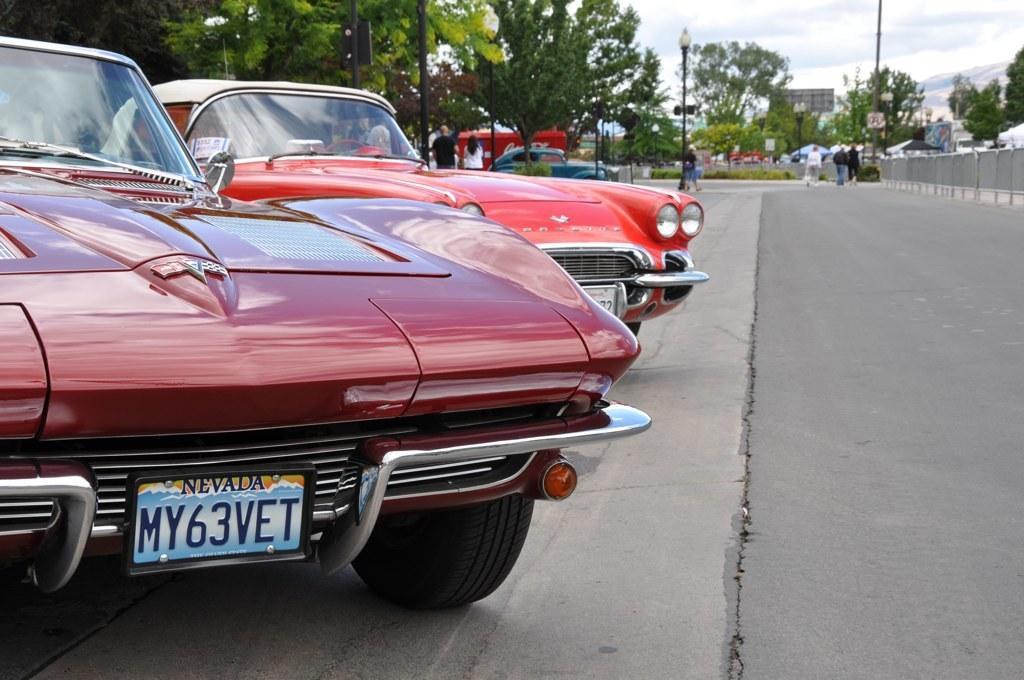How would you summarize this image in a sentence or two? In this image we can see cars, people, trees, light poles, road and in the background we can also see the sky. 